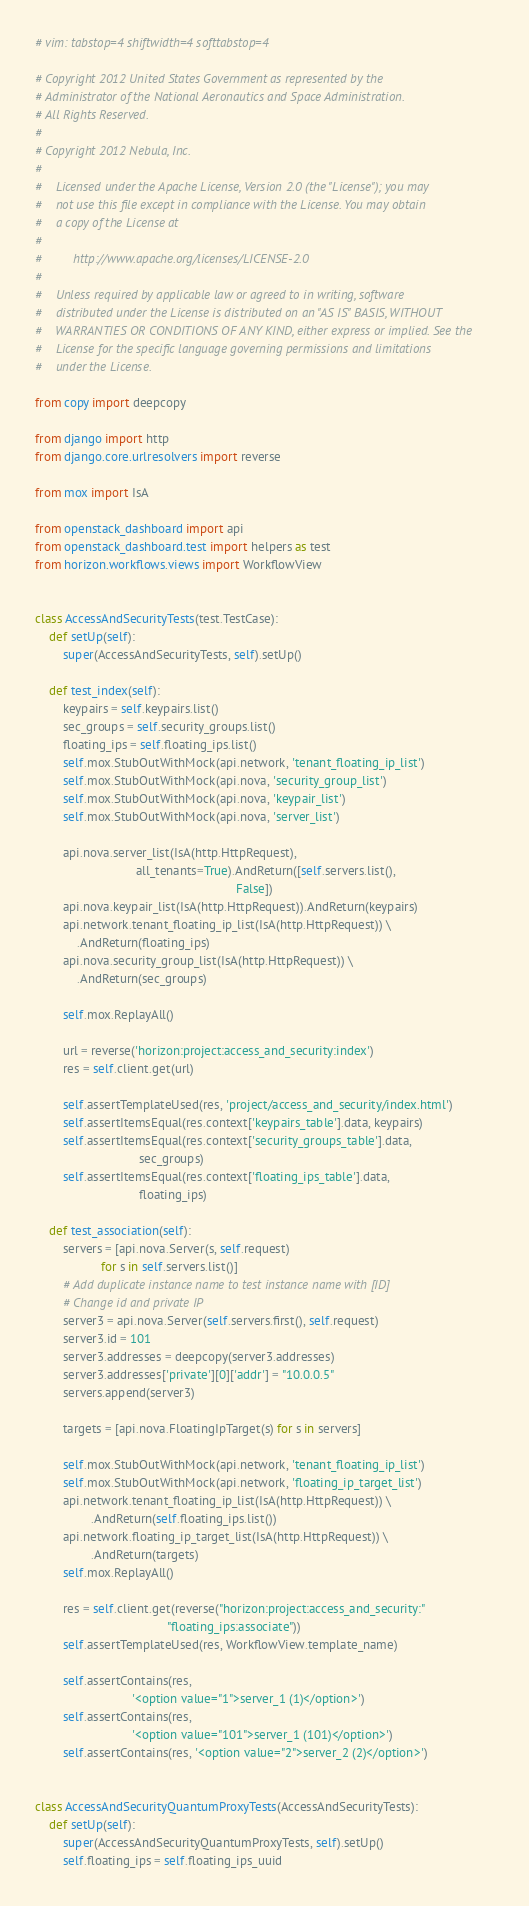Convert code to text. <code><loc_0><loc_0><loc_500><loc_500><_Python_># vim: tabstop=4 shiftwidth=4 softtabstop=4

# Copyright 2012 United States Government as represented by the
# Administrator of the National Aeronautics and Space Administration.
# All Rights Reserved.
#
# Copyright 2012 Nebula, Inc.
#
#    Licensed under the Apache License, Version 2.0 (the "License"); you may
#    not use this file except in compliance with the License. You may obtain
#    a copy of the License at
#
#         http://www.apache.org/licenses/LICENSE-2.0
#
#    Unless required by applicable law or agreed to in writing, software
#    distributed under the License is distributed on an "AS IS" BASIS, WITHOUT
#    WARRANTIES OR CONDITIONS OF ANY KIND, either express or implied. See the
#    License for the specific language governing permissions and limitations
#    under the License.

from copy import deepcopy

from django import http
from django.core.urlresolvers import reverse

from mox import IsA

from openstack_dashboard import api
from openstack_dashboard.test import helpers as test
from horizon.workflows.views import WorkflowView


class AccessAndSecurityTests(test.TestCase):
    def setUp(self):
        super(AccessAndSecurityTests, self).setUp()

    def test_index(self):
        keypairs = self.keypairs.list()
        sec_groups = self.security_groups.list()
        floating_ips = self.floating_ips.list()
        self.mox.StubOutWithMock(api.network, 'tenant_floating_ip_list')
        self.mox.StubOutWithMock(api.nova, 'security_group_list')
        self.mox.StubOutWithMock(api.nova, 'keypair_list')
        self.mox.StubOutWithMock(api.nova, 'server_list')

        api.nova.server_list(IsA(http.HttpRequest),
                             all_tenants=True).AndReturn([self.servers.list(),
                                                          False])
        api.nova.keypair_list(IsA(http.HttpRequest)).AndReturn(keypairs)
        api.network.tenant_floating_ip_list(IsA(http.HttpRequest)) \
            .AndReturn(floating_ips)
        api.nova.security_group_list(IsA(http.HttpRequest)) \
            .AndReturn(sec_groups)

        self.mox.ReplayAll()

        url = reverse('horizon:project:access_and_security:index')
        res = self.client.get(url)

        self.assertTemplateUsed(res, 'project/access_and_security/index.html')
        self.assertItemsEqual(res.context['keypairs_table'].data, keypairs)
        self.assertItemsEqual(res.context['security_groups_table'].data,
                              sec_groups)
        self.assertItemsEqual(res.context['floating_ips_table'].data,
                              floating_ips)

    def test_association(self):
        servers = [api.nova.Server(s, self.request)
                   for s in self.servers.list()]
        # Add duplicate instance name to test instance name with [ID]
        # Change id and private IP
        server3 = api.nova.Server(self.servers.first(), self.request)
        server3.id = 101
        server3.addresses = deepcopy(server3.addresses)
        server3.addresses['private'][0]['addr'] = "10.0.0.5"
        servers.append(server3)

        targets = [api.nova.FloatingIpTarget(s) for s in servers]

        self.mox.StubOutWithMock(api.network, 'tenant_floating_ip_list')
        self.mox.StubOutWithMock(api.network, 'floating_ip_target_list')
        api.network.tenant_floating_ip_list(IsA(http.HttpRequest)) \
                .AndReturn(self.floating_ips.list())
        api.network.floating_ip_target_list(IsA(http.HttpRequest)) \
                .AndReturn(targets)
        self.mox.ReplayAll()

        res = self.client.get(reverse("horizon:project:access_and_security:"
                                      "floating_ips:associate"))
        self.assertTemplateUsed(res, WorkflowView.template_name)

        self.assertContains(res,
                            '<option value="1">server_1 (1)</option>')
        self.assertContains(res,
                            '<option value="101">server_1 (101)</option>')
        self.assertContains(res, '<option value="2">server_2 (2)</option>')


class AccessAndSecurityQuantumProxyTests(AccessAndSecurityTests):
    def setUp(self):
        super(AccessAndSecurityQuantumProxyTests, self).setUp()
        self.floating_ips = self.floating_ips_uuid
</code> 